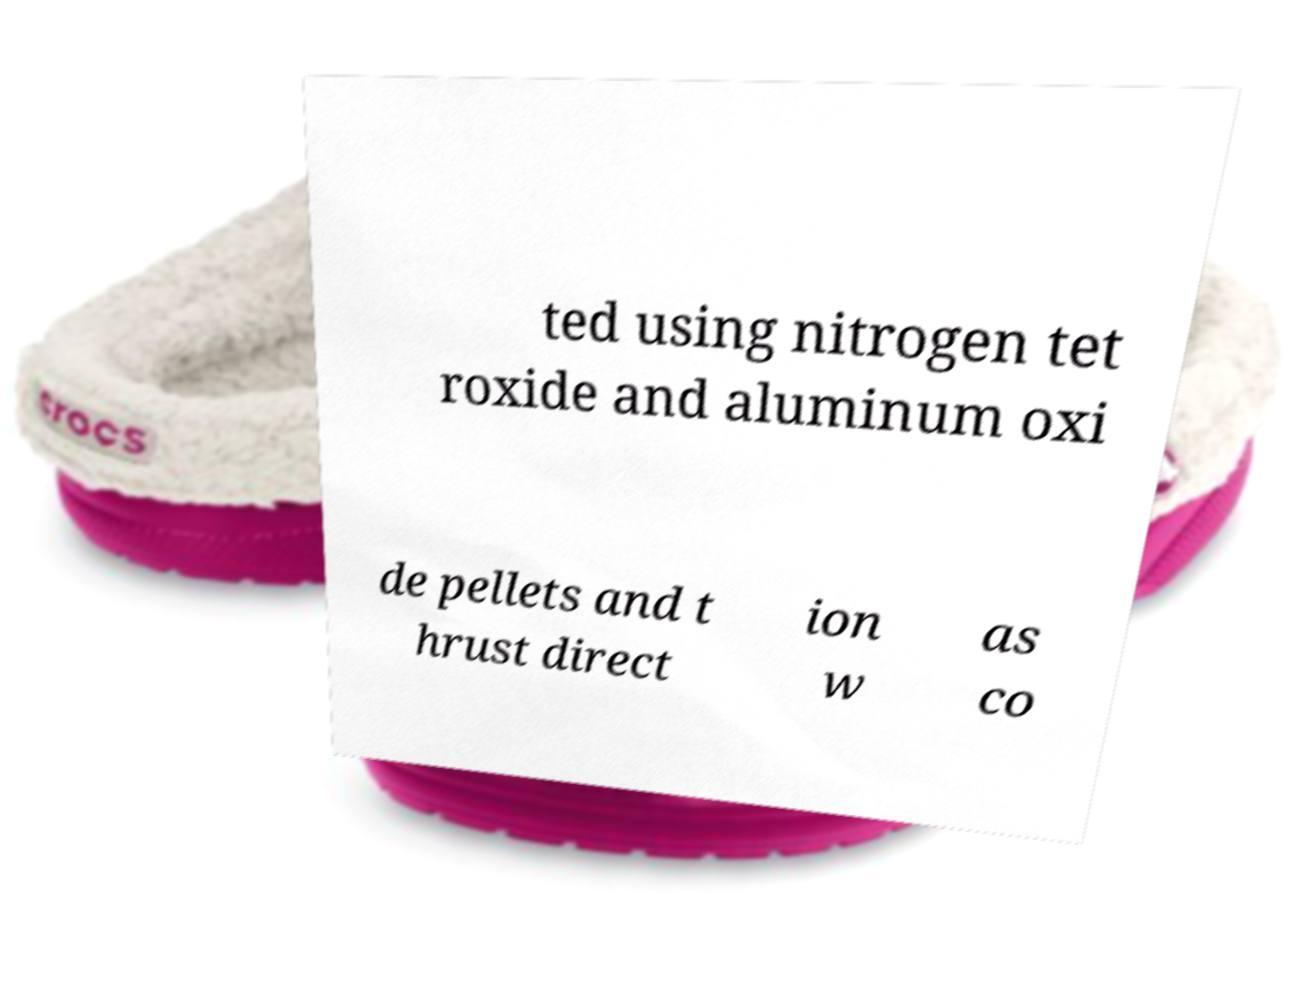I need the written content from this picture converted into text. Can you do that? ted using nitrogen tet roxide and aluminum oxi de pellets and t hrust direct ion w as co 